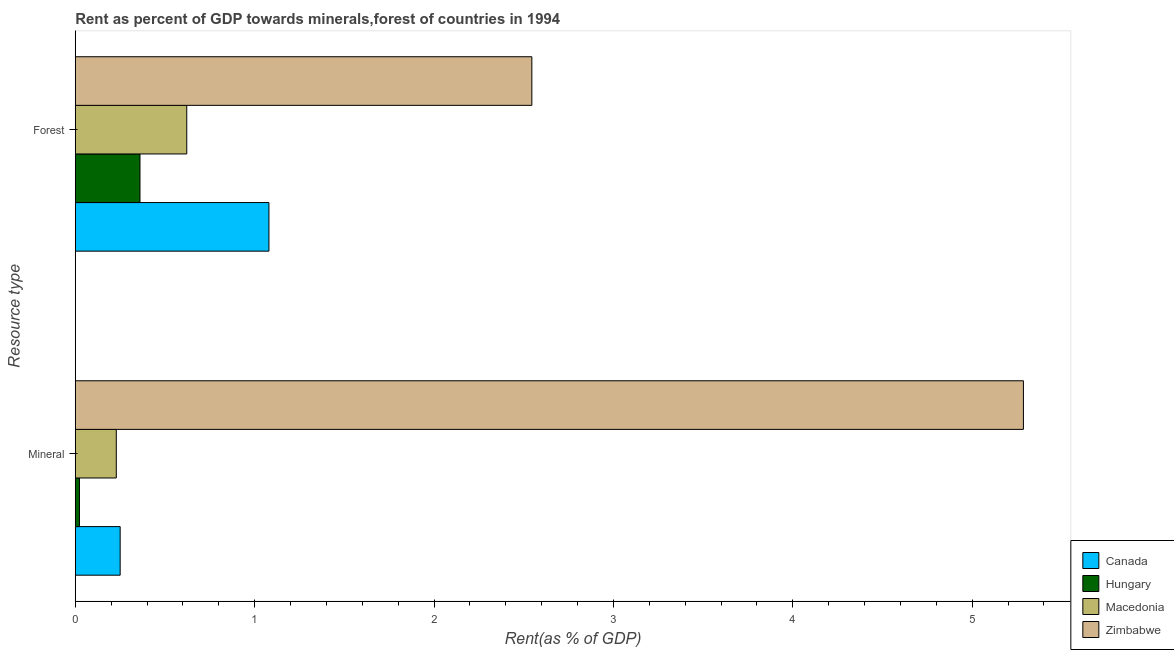How many different coloured bars are there?
Your answer should be compact. 4. Are the number of bars on each tick of the Y-axis equal?
Provide a short and direct response. Yes. How many bars are there on the 2nd tick from the top?
Keep it short and to the point. 4. What is the label of the 1st group of bars from the top?
Offer a very short reply. Forest. What is the mineral rent in Macedonia?
Give a very brief answer. 0.23. Across all countries, what is the maximum forest rent?
Provide a succinct answer. 2.55. Across all countries, what is the minimum mineral rent?
Your answer should be very brief. 0.02. In which country was the forest rent maximum?
Provide a succinct answer. Zimbabwe. In which country was the mineral rent minimum?
Offer a terse response. Hungary. What is the total forest rent in the graph?
Offer a terse response. 4.61. What is the difference between the mineral rent in Macedonia and that in Hungary?
Provide a short and direct response. 0.21. What is the difference between the forest rent in Zimbabwe and the mineral rent in Hungary?
Provide a short and direct response. 2.52. What is the average forest rent per country?
Your answer should be very brief. 1.15. What is the difference between the forest rent and mineral rent in Macedonia?
Keep it short and to the point. 0.39. In how many countries, is the forest rent greater than 2 %?
Make the answer very short. 1. What is the ratio of the mineral rent in Macedonia to that in Zimbabwe?
Make the answer very short. 0.04. Is the mineral rent in Macedonia less than that in Zimbabwe?
Ensure brevity in your answer.  Yes. What does the 1st bar from the top in Forest represents?
Your answer should be very brief. Zimbabwe. How many bars are there?
Offer a terse response. 8. Are the values on the major ticks of X-axis written in scientific E-notation?
Ensure brevity in your answer.  No. Where does the legend appear in the graph?
Offer a very short reply. Bottom right. What is the title of the graph?
Your response must be concise. Rent as percent of GDP towards minerals,forest of countries in 1994. What is the label or title of the X-axis?
Offer a terse response. Rent(as % of GDP). What is the label or title of the Y-axis?
Provide a short and direct response. Resource type. What is the Rent(as % of GDP) of Canada in Mineral?
Offer a terse response. 0.25. What is the Rent(as % of GDP) in Hungary in Mineral?
Make the answer very short. 0.02. What is the Rent(as % of GDP) in Macedonia in Mineral?
Your response must be concise. 0.23. What is the Rent(as % of GDP) of Zimbabwe in Mineral?
Your response must be concise. 5.29. What is the Rent(as % of GDP) in Canada in Forest?
Provide a succinct answer. 1.08. What is the Rent(as % of GDP) in Hungary in Forest?
Keep it short and to the point. 0.36. What is the Rent(as % of GDP) of Macedonia in Forest?
Provide a short and direct response. 0.62. What is the Rent(as % of GDP) of Zimbabwe in Forest?
Provide a short and direct response. 2.55. Across all Resource type, what is the maximum Rent(as % of GDP) in Canada?
Offer a terse response. 1.08. Across all Resource type, what is the maximum Rent(as % of GDP) in Hungary?
Your answer should be compact. 0.36. Across all Resource type, what is the maximum Rent(as % of GDP) of Macedonia?
Ensure brevity in your answer.  0.62. Across all Resource type, what is the maximum Rent(as % of GDP) of Zimbabwe?
Keep it short and to the point. 5.29. Across all Resource type, what is the minimum Rent(as % of GDP) in Canada?
Keep it short and to the point. 0.25. Across all Resource type, what is the minimum Rent(as % of GDP) of Hungary?
Your response must be concise. 0.02. Across all Resource type, what is the minimum Rent(as % of GDP) of Macedonia?
Give a very brief answer. 0.23. Across all Resource type, what is the minimum Rent(as % of GDP) in Zimbabwe?
Ensure brevity in your answer.  2.55. What is the total Rent(as % of GDP) of Canada in the graph?
Provide a short and direct response. 1.33. What is the total Rent(as % of GDP) in Hungary in the graph?
Keep it short and to the point. 0.38. What is the total Rent(as % of GDP) in Zimbabwe in the graph?
Your response must be concise. 7.83. What is the difference between the Rent(as % of GDP) in Canada in Mineral and that in Forest?
Your response must be concise. -0.83. What is the difference between the Rent(as % of GDP) in Hungary in Mineral and that in Forest?
Keep it short and to the point. -0.34. What is the difference between the Rent(as % of GDP) of Macedonia in Mineral and that in Forest?
Provide a succinct answer. -0.39. What is the difference between the Rent(as % of GDP) in Zimbabwe in Mineral and that in Forest?
Provide a short and direct response. 2.74. What is the difference between the Rent(as % of GDP) of Canada in Mineral and the Rent(as % of GDP) of Hungary in Forest?
Make the answer very short. -0.11. What is the difference between the Rent(as % of GDP) in Canada in Mineral and the Rent(as % of GDP) in Macedonia in Forest?
Offer a terse response. -0.37. What is the difference between the Rent(as % of GDP) in Canada in Mineral and the Rent(as % of GDP) in Zimbabwe in Forest?
Offer a terse response. -2.3. What is the difference between the Rent(as % of GDP) of Hungary in Mineral and the Rent(as % of GDP) of Macedonia in Forest?
Your answer should be compact. -0.6. What is the difference between the Rent(as % of GDP) in Hungary in Mineral and the Rent(as % of GDP) in Zimbabwe in Forest?
Give a very brief answer. -2.52. What is the difference between the Rent(as % of GDP) in Macedonia in Mineral and the Rent(as % of GDP) in Zimbabwe in Forest?
Your answer should be very brief. -2.32. What is the average Rent(as % of GDP) in Canada per Resource type?
Make the answer very short. 0.66. What is the average Rent(as % of GDP) in Hungary per Resource type?
Give a very brief answer. 0.19. What is the average Rent(as % of GDP) in Macedonia per Resource type?
Make the answer very short. 0.42. What is the average Rent(as % of GDP) of Zimbabwe per Resource type?
Your response must be concise. 3.92. What is the difference between the Rent(as % of GDP) of Canada and Rent(as % of GDP) of Hungary in Mineral?
Your response must be concise. 0.23. What is the difference between the Rent(as % of GDP) of Canada and Rent(as % of GDP) of Macedonia in Mineral?
Provide a succinct answer. 0.02. What is the difference between the Rent(as % of GDP) of Canada and Rent(as % of GDP) of Zimbabwe in Mineral?
Provide a succinct answer. -5.04. What is the difference between the Rent(as % of GDP) of Hungary and Rent(as % of GDP) of Macedonia in Mineral?
Ensure brevity in your answer.  -0.21. What is the difference between the Rent(as % of GDP) in Hungary and Rent(as % of GDP) in Zimbabwe in Mineral?
Your answer should be compact. -5.26. What is the difference between the Rent(as % of GDP) of Macedonia and Rent(as % of GDP) of Zimbabwe in Mineral?
Give a very brief answer. -5.06. What is the difference between the Rent(as % of GDP) of Canada and Rent(as % of GDP) of Hungary in Forest?
Give a very brief answer. 0.72. What is the difference between the Rent(as % of GDP) in Canada and Rent(as % of GDP) in Macedonia in Forest?
Ensure brevity in your answer.  0.46. What is the difference between the Rent(as % of GDP) of Canada and Rent(as % of GDP) of Zimbabwe in Forest?
Offer a terse response. -1.47. What is the difference between the Rent(as % of GDP) of Hungary and Rent(as % of GDP) of Macedonia in Forest?
Offer a terse response. -0.26. What is the difference between the Rent(as % of GDP) in Hungary and Rent(as % of GDP) in Zimbabwe in Forest?
Provide a succinct answer. -2.18. What is the difference between the Rent(as % of GDP) in Macedonia and Rent(as % of GDP) in Zimbabwe in Forest?
Offer a terse response. -1.92. What is the ratio of the Rent(as % of GDP) in Canada in Mineral to that in Forest?
Make the answer very short. 0.23. What is the ratio of the Rent(as % of GDP) in Hungary in Mineral to that in Forest?
Your response must be concise. 0.06. What is the ratio of the Rent(as % of GDP) of Macedonia in Mineral to that in Forest?
Ensure brevity in your answer.  0.37. What is the ratio of the Rent(as % of GDP) of Zimbabwe in Mineral to that in Forest?
Give a very brief answer. 2.08. What is the difference between the highest and the second highest Rent(as % of GDP) in Canada?
Ensure brevity in your answer.  0.83. What is the difference between the highest and the second highest Rent(as % of GDP) in Hungary?
Offer a terse response. 0.34. What is the difference between the highest and the second highest Rent(as % of GDP) of Macedonia?
Ensure brevity in your answer.  0.39. What is the difference between the highest and the second highest Rent(as % of GDP) in Zimbabwe?
Your answer should be very brief. 2.74. What is the difference between the highest and the lowest Rent(as % of GDP) in Canada?
Make the answer very short. 0.83. What is the difference between the highest and the lowest Rent(as % of GDP) in Hungary?
Give a very brief answer. 0.34. What is the difference between the highest and the lowest Rent(as % of GDP) in Macedonia?
Your answer should be compact. 0.39. What is the difference between the highest and the lowest Rent(as % of GDP) in Zimbabwe?
Provide a short and direct response. 2.74. 